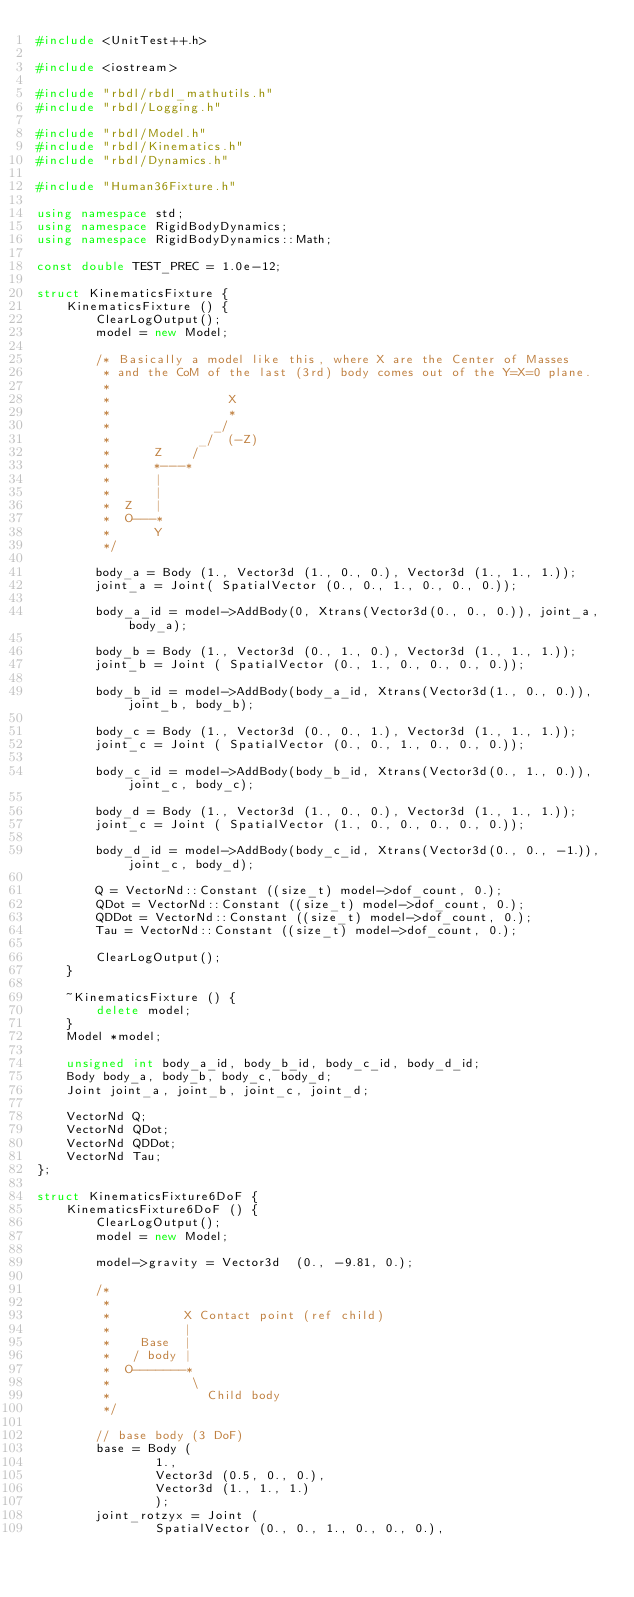Convert code to text. <code><loc_0><loc_0><loc_500><loc_500><_C++_>#include <UnitTest++.h>

#include <iostream>

#include "rbdl/rbdl_mathutils.h"
#include "rbdl/Logging.h"

#include "rbdl/Model.h"
#include "rbdl/Kinematics.h"
#include "rbdl/Dynamics.h"

#include "Human36Fixture.h"

using namespace std;
using namespace RigidBodyDynamics;
using namespace RigidBodyDynamics::Math;

const double TEST_PREC = 1.0e-12;

struct KinematicsFixture {
	KinematicsFixture () {
		ClearLogOutput();
		model = new Model;

		/* Basically a model like this, where X are the Center of Masses
		 * and the CoM of the last (3rd) body comes out of the Y=X=0 plane.
		 *
		 *                X
		 *                *
		 *              _/
		 *            _/  (-Z)
		 *      Z    /
		 *      *---* 
		 *      |
		 *      |
		 *  Z   |
		 *  O---*
		 *      Y
		 */

		body_a = Body (1., Vector3d (1., 0., 0.), Vector3d (1., 1., 1.));
		joint_a = Joint( SpatialVector (0., 0., 1., 0., 0., 0.));

		body_a_id = model->AddBody(0, Xtrans(Vector3d(0., 0., 0.)), joint_a, body_a);

		body_b = Body (1., Vector3d (0., 1., 0.), Vector3d (1., 1., 1.));
		joint_b = Joint ( SpatialVector (0., 1., 0., 0., 0., 0.));

		body_b_id = model->AddBody(body_a_id, Xtrans(Vector3d(1., 0., 0.)), joint_b, body_b);

		body_c = Body (1., Vector3d (0., 0., 1.), Vector3d (1., 1., 1.));
		joint_c = Joint ( SpatialVector (0., 0., 1., 0., 0., 0.));

		body_c_id = model->AddBody(body_b_id, Xtrans(Vector3d(0., 1., 0.)), joint_c, body_c);

		body_d = Body (1., Vector3d (1., 0., 0.), Vector3d (1., 1., 1.));
		joint_c = Joint ( SpatialVector (1., 0., 0., 0., 0., 0.));

		body_d_id = model->AddBody(body_c_id, Xtrans(Vector3d(0., 0., -1.)), joint_c, body_d);

		Q = VectorNd::Constant ((size_t) model->dof_count, 0.);
		QDot = VectorNd::Constant ((size_t) model->dof_count, 0.);
		QDDot = VectorNd::Constant ((size_t) model->dof_count, 0.);
		Tau = VectorNd::Constant ((size_t) model->dof_count, 0.);

		ClearLogOutput();
	}
	
	~KinematicsFixture () {
		delete model;
	}
	Model *model;

	unsigned int body_a_id, body_b_id, body_c_id, body_d_id;
	Body body_a, body_b, body_c, body_d;
	Joint joint_a, joint_b, joint_c, joint_d;

	VectorNd Q;
	VectorNd QDot;
	VectorNd QDDot;
	VectorNd Tau;
};

struct KinematicsFixture6DoF {
	KinematicsFixture6DoF () {
		ClearLogOutput();
		model = new Model;

		model->gravity = Vector3d  (0., -9.81, 0.);

		/* 
		 *
		 *          X Contact point (ref child)
		 *          |
		 *    Base  |
		 *   / body |
		 *  O-------*
		 *           \
		 *             Child body
		 */

		// base body (3 DoF)
		base = Body (
				1.,
				Vector3d (0.5, 0., 0.),
				Vector3d (1., 1., 1.)
				);
		joint_rotzyx = Joint (
				SpatialVector (0., 0., 1., 0., 0., 0.),</code> 